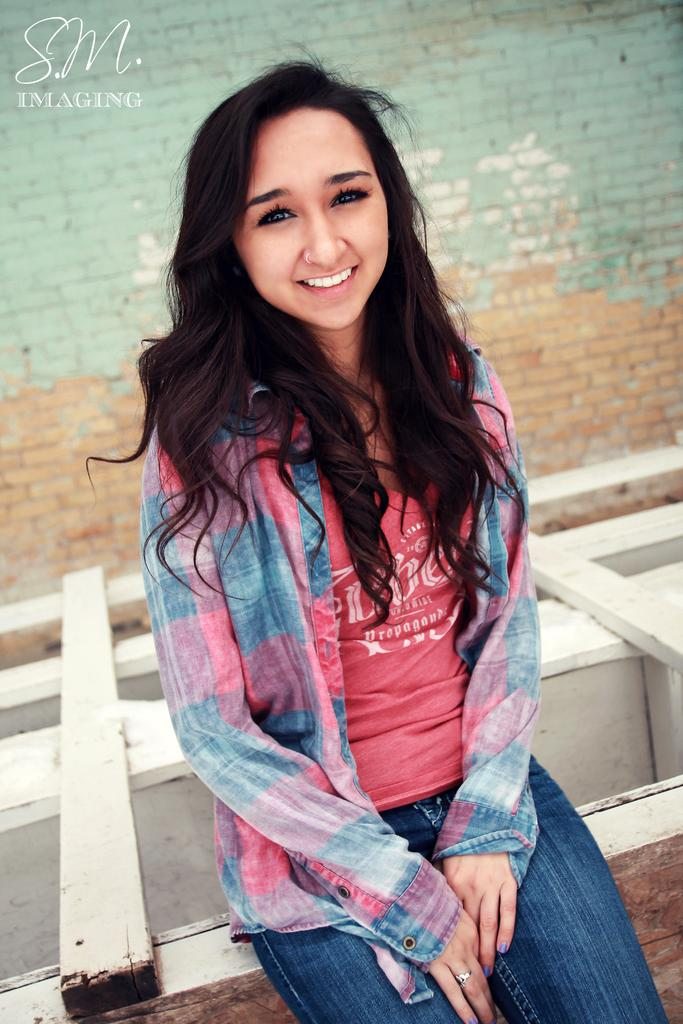What is the expression on the girl's face in the image? The girl in the image is smiling. What direction is the girl looking in the image? The girl is looking forward. What type of structure can be seen in the background of the image? There is a brick wall in the background of the image. What material is the surface that the girl is standing on or near? There is a wooden surface in the image. Can you describe any additional features or elements in the image? There is a watermark in the left side corner of the image. Can you tell me how many hens are present in the image? There are no hens present in the image; it features a girl standing near a wooden surface with a brick wall in the background. What type of hope can be seen in the image? There is no specific type of hope depicted in the image; it is a photograph of a girl with a particular expression and setting. 